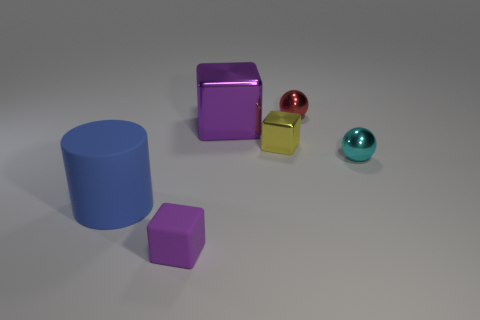There is a rubber thing that is the same color as the large metal cube; what is its shape?
Offer a terse response. Cube. There is a big object that is the same color as the rubber cube; what material is it?
Give a very brief answer. Metal. How many large red cylinders are made of the same material as the cyan object?
Make the answer very short. 0. Is the number of large blue objects left of the cylinder less than the number of large metallic objects that are to the right of the tiny yellow cube?
Provide a short and direct response. No. The tiny cube that is behind the object that is on the right side of the tiny thing that is behind the yellow metallic cube is made of what material?
Give a very brief answer. Metal. There is a object that is both behind the cylinder and in front of the tiny yellow cube; what is its size?
Make the answer very short. Small. What number of cylinders are small cyan shiny things or big rubber objects?
Your answer should be very brief. 1. What color is the sphere that is the same size as the red thing?
Provide a succinct answer. Cyan. Is there any other thing that has the same shape as the big matte thing?
Provide a short and direct response. No. The other tiny object that is the same shape as the red object is what color?
Make the answer very short. Cyan. 